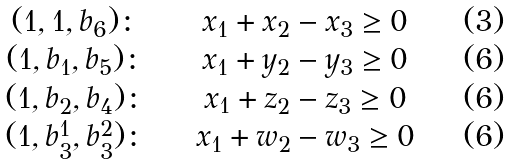<formula> <loc_0><loc_0><loc_500><loc_500>\begin{array} { c c c } ( 1 , 1 , b _ { 6 } ) \colon & \quad x _ { 1 } + x _ { 2 } - x _ { 3 } \geq 0 & \quad ( 3 ) \\ ( 1 , b _ { 1 } , b _ { 5 } ) \colon & \quad x _ { 1 } + y _ { 2 } - y _ { 3 } \geq 0 & \quad ( 6 ) \\ ( 1 , b _ { 2 } , b _ { 4 } ) \colon & \quad x _ { 1 } + z _ { 2 } - z _ { 3 } \geq 0 & \quad ( 6 ) \\ ( 1 , b _ { 3 } ^ { 1 } , b _ { 3 } ^ { 2 } ) \colon & \quad x _ { 1 } + w _ { 2 } - w _ { 3 } \geq 0 & \quad ( 6 ) \\ \end{array}</formula> 